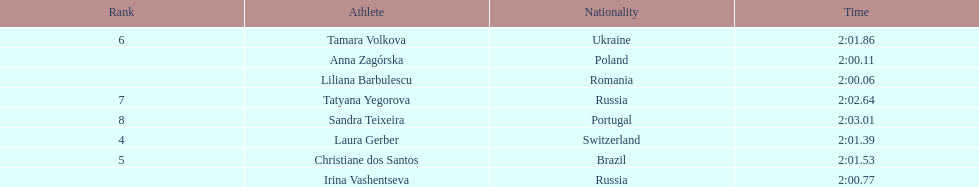How many runners finished with their time below 2:01? 3. 